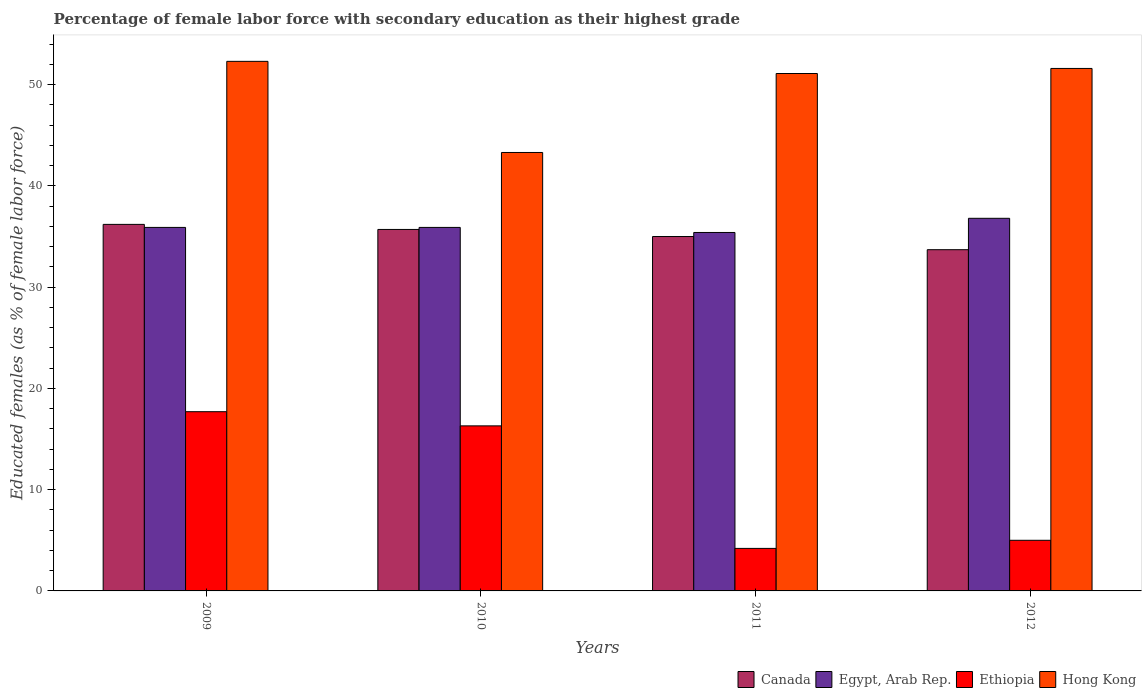Are the number of bars on each tick of the X-axis equal?
Your response must be concise. Yes. How many bars are there on the 4th tick from the left?
Your answer should be very brief. 4. What is the percentage of female labor force with secondary education in Egypt, Arab Rep. in 2012?
Your answer should be compact. 36.8. Across all years, what is the maximum percentage of female labor force with secondary education in Hong Kong?
Your answer should be very brief. 52.3. Across all years, what is the minimum percentage of female labor force with secondary education in Ethiopia?
Keep it short and to the point. 4.2. In which year was the percentage of female labor force with secondary education in Ethiopia minimum?
Ensure brevity in your answer.  2011. What is the total percentage of female labor force with secondary education in Ethiopia in the graph?
Ensure brevity in your answer.  43.2. What is the difference between the percentage of female labor force with secondary education in Canada in 2010 and that in 2011?
Make the answer very short. 0.7. What is the difference between the percentage of female labor force with secondary education in Hong Kong in 2009 and the percentage of female labor force with secondary education in Canada in 2012?
Ensure brevity in your answer.  18.6. What is the average percentage of female labor force with secondary education in Egypt, Arab Rep. per year?
Ensure brevity in your answer.  36. In the year 2009, what is the difference between the percentage of female labor force with secondary education in Canada and percentage of female labor force with secondary education in Hong Kong?
Make the answer very short. -16.1. What is the ratio of the percentage of female labor force with secondary education in Hong Kong in 2009 to that in 2010?
Provide a short and direct response. 1.21. Is the difference between the percentage of female labor force with secondary education in Canada in 2011 and 2012 greater than the difference between the percentage of female labor force with secondary education in Hong Kong in 2011 and 2012?
Make the answer very short. Yes. What is the difference between the highest and the second highest percentage of female labor force with secondary education in Canada?
Your answer should be compact. 0.5. What is the difference between the highest and the lowest percentage of female labor force with secondary education in Ethiopia?
Make the answer very short. 13.5. Is the sum of the percentage of female labor force with secondary education in Canada in 2010 and 2011 greater than the maximum percentage of female labor force with secondary education in Ethiopia across all years?
Your answer should be very brief. Yes. Is it the case that in every year, the sum of the percentage of female labor force with secondary education in Canada and percentage of female labor force with secondary education in Hong Kong is greater than the sum of percentage of female labor force with secondary education in Egypt, Arab Rep. and percentage of female labor force with secondary education in Ethiopia?
Your response must be concise. No. What does the 4th bar from the left in 2012 represents?
Your answer should be compact. Hong Kong. What does the 1st bar from the right in 2011 represents?
Keep it short and to the point. Hong Kong. Is it the case that in every year, the sum of the percentage of female labor force with secondary education in Canada and percentage of female labor force with secondary education in Hong Kong is greater than the percentage of female labor force with secondary education in Egypt, Arab Rep.?
Make the answer very short. Yes. How many bars are there?
Keep it short and to the point. 16. Are all the bars in the graph horizontal?
Give a very brief answer. No. What is the difference between two consecutive major ticks on the Y-axis?
Your answer should be very brief. 10. Does the graph contain any zero values?
Your answer should be compact. No. Where does the legend appear in the graph?
Offer a terse response. Bottom right. How many legend labels are there?
Provide a succinct answer. 4. How are the legend labels stacked?
Your response must be concise. Horizontal. What is the title of the graph?
Provide a short and direct response. Percentage of female labor force with secondary education as their highest grade. Does "Fiji" appear as one of the legend labels in the graph?
Keep it short and to the point. No. What is the label or title of the X-axis?
Offer a very short reply. Years. What is the label or title of the Y-axis?
Provide a succinct answer. Educated females (as % of female labor force). What is the Educated females (as % of female labor force) in Canada in 2009?
Your response must be concise. 36.2. What is the Educated females (as % of female labor force) in Egypt, Arab Rep. in 2009?
Your response must be concise. 35.9. What is the Educated females (as % of female labor force) of Ethiopia in 2009?
Make the answer very short. 17.7. What is the Educated females (as % of female labor force) in Hong Kong in 2009?
Provide a short and direct response. 52.3. What is the Educated females (as % of female labor force) in Canada in 2010?
Offer a terse response. 35.7. What is the Educated females (as % of female labor force) of Egypt, Arab Rep. in 2010?
Ensure brevity in your answer.  35.9. What is the Educated females (as % of female labor force) in Ethiopia in 2010?
Give a very brief answer. 16.3. What is the Educated females (as % of female labor force) in Hong Kong in 2010?
Make the answer very short. 43.3. What is the Educated females (as % of female labor force) in Canada in 2011?
Provide a succinct answer. 35. What is the Educated females (as % of female labor force) of Egypt, Arab Rep. in 2011?
Offer a terse response. 35.4. What is the Educated females (as % of female labor force) in Ethiopia in 2011?
Keep it short and to the point. 4.2. What is the Educated females (as % of female labor force) of Hong Kong in 2011?
Ensure brevity in your answer.  51.1. What is the Educated females (as % of female labor force) of Canada in 2012?
Ensure brevity in your answer.  33.7. What is the Educated females (as % of female labor force) in Egypt, Arab Rep. in 2012?
Offer a very short reply. 36.8. What is the Educated females (as % of female labor force) of Ethiopia in 2012?
Offer a terse response. 5. What is the Educated females (as % of female labor force) in Hong Kong in 2012?
Ensure brevity in your answer.  51.6. Across all years, what is the maximum Educated females (as % of female labor force) in Canada?
Provide a short and direct response. 36.2. Across all years, what is the maximum Educated females (as % of female labor force) in Egypt, Arab Rep.?
Ensure brevity in your answer.  36.8. Across all years, what is the maximum Educated females (as % of female labor force) in Ethiopia?
Your answer should be very brief. 17.7. Across all years, what is the maximum Educated females (as % of female labor force) in Hong Kong?
Ensure brevity in your answer.  52.3. Across all years, what is the minimum Educated females (as % of female labor force) of Canada?
Your response must be concise. 33.7. Across all years, what is the minimum Educated females (as % of female labor force) of Egypt, Arab Rep.?
Your response must be concise. 35.4. Across all years, what is the minimum Educated females (as % of female labor force) in Ethiopia?
Your answer should be very brief. 4.2. Across all years, what is the minimum Educated females (as % of female labor force) in Hong Kong?
Your answer should be compact. 43.3. What is the total Educated females (as % of female labor force) of Canada in the graph?
Offer a very short reply. 140.6. What is the total Educated females (as % of female labor force) in Egypt, Arab Rep. in the graph?
Offer a very short reply. 144. What is the total Educated females (as % of female labor force) of Ethiopia in the graph?
Provide a succinct answer. 43.2. What is the total Educated females (as % of female labor force) in Hong Kong in the graph?
Make the answer very short. 198.3. What is the difference between the Educated females (as % of female labor force) in Canada in 2009 and that in 2010?
Offer a terse response. 0.5. What is the difference between the Educated females (as % of female labor force) in Ethiopia in 2009 and that in 2010?
Provide a succinct answer. 1.4. What is the difference between the Educated females (as % of female labor force) of Egypt, Arab Rep. in 2009 and that in 2011?
Offer a very short reply. 0.5. What is the difference between the Educated females (as % of female labor force) of Ethiopia in 2009 and that in 2011?
Offer a very short reply. 13.5. What is the difference between the Educated females (as % of female labor force) in Canada in 2009 and that in 2012?
Ensure brevity in your answer.  2.5. What is the difference between the Educated females (as % of female labor force) of Ethiopia in 2009 and that in 2012?
Offer a very short reply. 12.7. What is the difference between the Educated females (as % of female labor force) in Hong Kong in 2009 and that in 2012?
Offer a terse response. 0.7. What is the difference between the Educated females (as % of female labor force) in Egypt, Arab Rep. in 2010 and that in 2011?
Give a very brief answer. 0.5. What is the difference between the Educated females (as % of female labor force) of Hong Kong in 2010 and that in 2011?
Offer a very short reply. -7.8. What is the difference between the Educated females (as % of female labor force) of Canada in 2010 and that in 2012?
Keep it short and to the point. 2. What is the difference between the Educated females (as % of female labor force) of Egypt, Arab Rep. in 2010 and that in 2012?
Ensure brevity in your answer.  -0.9. What is the difference between the Educated females (as % of female labor force) in Ethiopia in 2010 and that in 2012?
Offer a terse response. 11.3. What is the difference between the Educated females (as % of female labor force) of Egypt, Arab Rep. in 2011 and that in 2012?
Your answer should be compact. -1.4. What is the difference between the Educated females (as % of female labor force) in Ethiopia in 2011 and that in 2012?
Offer a very short reply. -0.8. What is the difference between the Educated females (as % of female labor force) in Hong Kong in 2011 and that in 2012?
Give a very brief answer. -0.5. What is the difference between the Educated females (as % of female labor force) in Canada in 2009 and the Educated females (as % of female labor force) in Hong Kong in 2010?
Your answer should be compact. -7.1. What is the difference between the Educated females (as % of female labor force) in Egypt, Arab Rep. in 2009 and the Educated females (as % of female labor force) in Ethiopia in 2010?
Offer a terse response. 19.6. What is the difference between the Educated females (as % of female labor force) in Egypt, Arab Rep. in 2009 and the Educated females (as % of female labor force) in Hong Kong in 2010?
Ensure brevity in your answer.  -7.4. What is the difference between the Educated females (as % of female labor force) of Ethiopia in 2009 and the Educated females (as % of female labor force) of Hong Kong in 2010?
Your response must be concise. -25.6. What is the difference between the Educated females (as % of female labor force) of Canada in 2009 and the Educated females (as % of female labor force) of Egypt, Arab Rep. in 2011?
Make the answer very short. 0.8. What is the difference between the Educated females (as % of female labor force) of Canada in 2009 and the Educated females (as % of female labor force) of Hong Kong in 2011?
Ensure brevity in your answer.  -14.9. What is the difference between the Educated females (as % of female labor force) in Egypt, Arab Rep. in 2009 and the Educated females (as % of female labor force) in Ethiopia in 2011?
Keep it short and to the point. 31.7. What is the difference between the Educated females (as % of female labor force) of Egypt, Arab Rep. in 2009 and the Educated females (as % of female labor force) of Hong Kong in 2011?
Ensure brevity in your answer.  -15.2. What is the difference between the Educated females (as % of female labor force) of Ethiopia in 2009 and the Educated females (as % of female labor force) of Hong Kong in 2011?
Make the answer very short. -33.4. What is the difference between the Educated females (as % of female labor force) of Canada in 2009 and the Educated females (as % of female labor force) of Egypt, Arab Rep. in 2012?
Your answer should be very brief. -0.6. What is the difference between the Educated females (as % of female labor force) of Canada in 2009 and the Educated females (as % of female labor force) of Ethiopia in 2012?
Provide a succinct answer. 31.2. What is the difference between the Educated females (as % of female labor force) in Canada in 2009 and the Educated females (as % of female labor force) in Hong Kong in 2012?
Make the answer very short. -15.4. What is the difference between the Educated females (as % of female labor force) in Egypt, Arab Rep. in 2009 and the Educated females (as % of female labor force) in Ethiopia in 2012?
Your answer should be compact. 30.9. What is the difference between the Educated females (as % of female labor force) of Egypt, Arab Rep. in 2009 and the Educated females (as % of female labor force) of Hong Kong in 2012?
Give a very brief answer. -15.7. What is the difference between the Educated females (as % of female labor force) of Ethiopia in 2009 and the Educated females (as % of female labor force) of Hong Kong in 2012?
Your answer should be compact. -33.9. What is the difference between the Educated females (as % of female labor force) in Canada in 2010 and the Educated females (as % of female labor force) in Ethiopia in 2011?
Your answer should be compact. 31.5. What is the difference between the Educated females (as % of female labor force) in Canada in 2010 and the Educated females (as % of female labor force) in Hong Kong in 2011?
Give a very brief answer. -15.4. What is the difference between the Educated females (as % of female labor force) in Egypt, Arab Rep. in 2010 and the Educated females (as % of female labor force) in Ethiopia in 2011?
Your answer should be compact. 31.7. What is the difference between the Educated females (as % of female labor force) of Egypt, Arab Rep. in 2010 and the Educated females (as % of female labor force) of Hong Kong in 2011?
Give a very brief answer. -15.2. What is the difference between the Educated females (as % of female labor force) in Ethiopia in 2010 and the Educated females (as % of female labor force) in Hong Kong in 2011?
Offer a very short reply. -34.8. What is the difference between the Educated females (as % of female labor force) in Canada in 2010 and the Educated females (as % of female labor force) in Ethiopia in 2012?
Give a very brief answer. 30.7. What is the difference between the Educated females (as % of female labor force) in Canada in 2010 and the Educated females (as % of female labor force) in Hong Kong in 2012?
Offer a terse response. -15.9. What is the difference between the Educated females (as % of female labor force) of Egypt, Arab Rep. in 2010 and the Educated females (as % of female labor force) of Ethiopia in 2012?
Provide a succinct answer. 30.9. What is the difference between the Educated females (as % of female labor force) in Egypt, Arab Rep. in 2010 and the Educated females (as % of female labor force) in Hong Kong in 2012?
Provide a short and direct response. -15.7. What is the difference between the Educated females (as % of female labor force) in Ethiopia in 2010 and the Educated females (as % of female labor force) in Hong Kong in 2012?
Give a very brief answer. -35.3. What is the difference between the Educated females (as % of female labor force) in Canada in 2011 and the Educated females (as % of female labor force) in Egypt, Arab Rep. in 2012?
Your answer should be very brief. -1.8. What is the difference between the Educated females (as % of female labor force) in Canada in 2011 and the Educated females (as % of female labor force) in Ethiopia in 2012?
Provide a short and direct response. 30. What is the difference between the Educated females (as % of female labor force) of Canada in 2011 and the Educated females (as % of female labor force) of Hong Kong in 2012?
Provide a succinct answer. -16.6. What is the difference between the Educated females (as % of female labor force) of Egypt, Arab Rep. in 2011 and the Educated females (as % of female labor force) of Ethiopia in 2012?
Make the answer very short. 30.4. What is the difference between the Educated females (as % of female labor force) of Egypt, Arab Rep. in 2011 and the Educated females (as % of female labor force) of Hong Kong in 2012?
Your answer should be compact. -16.2. What is the difference between the Educated females (as % of female labor force) in Ethiopia in 2011 and the Educated females (as % of female labor force) in Hong Kong in 2012?
Your answer should be compact. -47.4. What is the average Educated females (as % of female labor force) of Canada per year?
Your response must be concise. 35.15. What is the average Educated females (as % of female labor force) of Ethiopia per year?
Provide a short and direct response. 10.8. What is the average Educated females (as % of female labor force) in Hong Kong per year?
Make the answer very short. 49.58. In the year 2009, what is the difference between the Educated females (as % of female labor force) in Canada and Educated females (as % of female labor force) in Egypt, Arab Rep.?
Your answer should be compact. 0.3. In the year 2009, what is the difference between the Educated females (as % of female labor force) of Canada and Educated females (as % of female labor force) of Hong Kong?
Ensure brevity in your answer.  -16.1. In the year 2009, what is the difference between the Educated females (as % of female labor force) in Egypt, Arab Rep. and Educated females (as % of female labor force) in Ethiopia?
Provide a succinct answer. 18.2. In the year 2009, what is the difference between the Educated females (as % of female labor force) of Egypt, Arab Rep. and Educated females (as % of female labor force) of Hong Kong?
Give a very brief answer. -16.4. In the year 2009, what is the difference between the Educated females (as % of female labor force) of Ethiopia and Educated females (as % of female labor force) of Hong Kong?
Your answer should be very brief. -34.6. In the year 2010, what is the difference between the Educated females (as % of female labor force) of Canada and Educated females (as % of female labor force) of Egypt, Arab Rep.?
Keep it short and to the point. -0.2. In the year 2010, what is the difference between the Educated females (as % of female labor force) of Canada and Educated females (as % of female labor force) of Ethiopia?
Keep it short and to the point. 19.4. In the year 2010, what is the difference between the Educated females (as % of female labor force) of Canada and Educated females (as % of female labor force) of Hong Kong?
Offer a very short reply. -7.6. In the year 2010, what is the difference between the Educated females (as % of female labor force) in Egypt, Arab Rep. and Educated females (as % of female labor force) in Ethiopia?
Offer a very short reply. 19.6. In the year 2011, what is the difference between the Educated females (as % of female labor force) in Canada and Educated females (as % of female labor force) in Ethiopia?
Offer a terse response. 30.8. In the year 2011, what is the difference between the Educated females (as % of female labor force) of Canada and Educated females (as % of female labor force) of Hong Kong?
Offer a terse response. -16.1. In the year 2011, what is the difference between the Educated females (as % of female labor force) in Egypt, Arab Rep. and Educated females (as % of female labor force) in Ethiopia?
Your answer should be compact. 31.2. In the year 2011, what is the difference between the Educated females (as % of female labor force) of Egypt, Arab Rep. and Educated females (as % of female labor force) of Hong Kong?
Ensure brevity in your answer.  -15.7. In the year 2011, what is the difference between the Educated females (as % of female labor force) in Ethiopia and Educated females (as % of female labor force) in Hong Kong?
Give a very brief answer. -46.9. In the year 2012, what is the difference between the Educated females (as % of female labor force) of Canada and Educated females (as % of female labor force) of Ethiopia?
Your answer should be compact. 28.7. In the year 2012, what is the difference between the Educated females (as % of female labor force) in Canada and Educated females (as % of female labor force) in Hong Kong?
Ensure brevity in your answer.  -17.9. In the year 2012, what is the difference between the Educated females (as % of female labor force) in Egypt, Arab Rep. and Educated females (as % of female labor force) in Ethiopia?
Make the answer very short. 31.8. In the year 2012, what is the difference between the Educated females (as % of female labor force) in Egypt, Arab Rep. and Educated females (as % of female labor force) in Hong Kong?
Your answer should be very brief. -14.8. In the year 2012, what is the difference between the Educated females (as % of female labor force) of Ethiopia and Educated females (as % of female labor force) of Hong Kong?
Offer a terse response. -46.6. What is the ratio of the Educated females (as % of female labor force) of Canada in 2009 to that in 2010?
Keep it short and to the point. 1.01. What is the ratio of the Educated females (as % of female labor force) of Egypt, Arab Rep. in 2009 to that in 2010?
Ensure brevity in your answer.  1. What is the ratio of the Educated females (as % of female labor force) of Ethiopia in 2009 to that in 2010?
Keep it short and to the point. 1.09. What is the ratio of the Educated females (as % of female labor force) of Hong Kong in 2009 to that in 2010?
Offer a terse response. 1.21. What is the ratio of the Educated females (as % of female labor force) of Canada in 2009 to that in 2011?
Ensure brevity in your answer.  1.03. What is the ratio of the Educated females (as % of female labor force) of Egypt, Arab Rep. in 2009 to that in 2011?
Your response must be concise. 1.01. What is the ratio of the Educated females (as % of female labor force) of Ethiopia in 2009 to that in 2011?
Keep it short and to the point. 4.21. What is the ratio of the Educated females (as % of female labor force) of Hong Kong in 2009 to that in 2011?
Give a very brief answer. 1.02. What is the ratio of the Educated females (as % of female labor force) in Canada in 2009 to that in 2012?
Keep it short and to the point. 1.07. What is the ratio of the Educated females (as % of female labor force) of Egypt, Arab Rep. in 2009 to that in 2012?
Keep it short and to the point. 0.98. What is the ratio of the Educated females (as % of female labor force) in Ethiopia in 2009 to that in 2012?
Your response must be concise. 3.54. What is the ratio of the Educated females (as % of female labor force) of Hong Kong in 2009 to that in 2012?
Your response must be concise. 1.01. What is the ratio of the Educated females (as % of female labor force) of Canada in 2010 to that in 2011?
Your answer should be very brief. 1.02. What is the ratio of the Educated females (as % of female labor force) of Egypt, Arab Rep. in 2010 to that in 2011?
Keep it short and to the point. 1.01. What is the ratio of the Educated females (as % of female labor force) of Ethiopia in 2010 to that in 2011?
Offer a terse response. 3.88. What is the ratio of the Educated females (as % of female labor force) of Hong Kong in 2010 to that in 2011?
Provide a succinct answer. 0.85. What is the ratio of the Educated females (as % of female labor force) in Canada in 2010 to that in 2012?
Offer a very short reply. 1.06. What is the ratio of the Educated females (as % of female labor force) of Egypt, Arab Rep. in 2010 to that in 2012?
Provide a succinct answer. 0.98. What is the ratio of the Educated females (as % of female labor force) of Ethiopia in 2010 to that in 2012?
Ensure brevity in your answer.  3.26. What is the ratio of the Educated females (as % of female labor force) of Hong Kong in 2010 to that in 2012?
Your answer should be compact. 0.84. What is the ratio of the Educated females (as % of female labor force) of Canada in 2011 to that in 2012?
Give a very brief answer. 1.04. What is the ratio of the Educated females (as % of female labor force) of Egypt, Arab Rep. in 2011 to that in 2012?
Make the answer very short. 0.96. What is the ratio of the Educated females (as % of female labor force) in Ethiopia in 2011 to that in 2012?
Provide a succinct answer. 0.84. What is the ratio of the Educated females (as % of female labor force) of Hong Kong in 2011 to that in 2012?
Make the answer very short. 0.99. What is the difference between the highest and the second highest Educated females (as % of female labor force) of Canada?
Offer a very short reply. 0.5. What is the difference between the highest and the second highest Educated females (as % of female labor force) of Ethiopia?
Your answer should be compact. 1.4. What is the difference between the highest and the lowest Educated females (as % of female labor force) in Canada?
Your answer should be compact. 2.5. What is the difference between the highest and the lowest Educated females (as % of female labor force) in Egypt, Arab Rep.?
Provide a short and direct response. 1.4. What is the difference between the highest and the lowest Educated females (as % of female labor force) in Ethiopia?
Give a very brief answer. 13.5. 